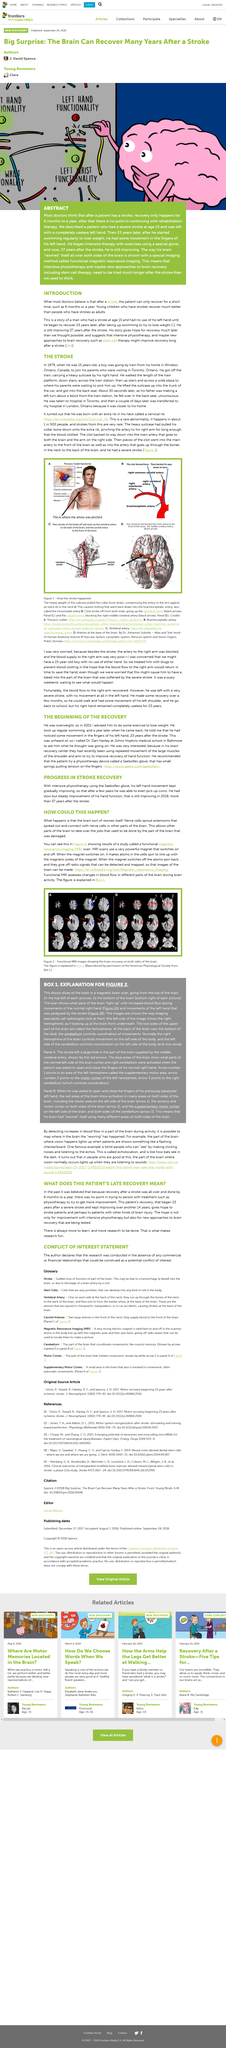Specify some key components in this picture. The extra rib was located in the neck. Figure 2 shows functional MRI images. Magnetic resonance imaging (MRI) is the special imaging method used to show how a patient's brain rewires itself, enabling the visualization of brain activity and plasticity. The method used to demonstrate how a patient's brain rewires itself is functional magnetic resonance imaging, a specialized imaging technique. The boy was 15 years old. 